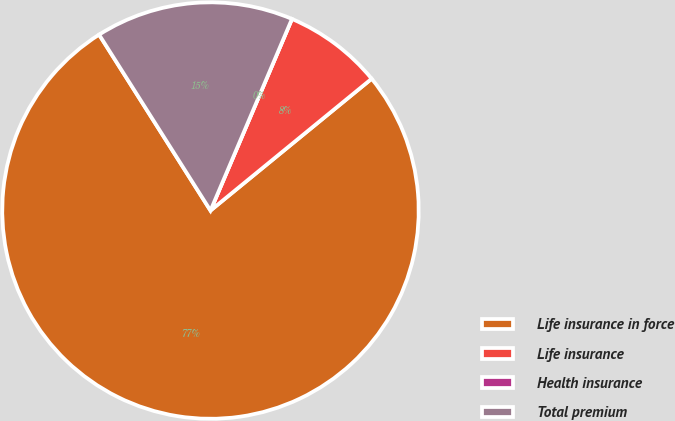<chart> <loc_0><loc_0><loc_500><loc_500><pie_chart><fcel>Life insurance in force<fcel>Life insurance<fcel>Health insurance<fcel>Total premium<nl><fcel>76.92%<fcel>7.69%<fcel>0.0%<fcel>15.38%<nl></chart> 